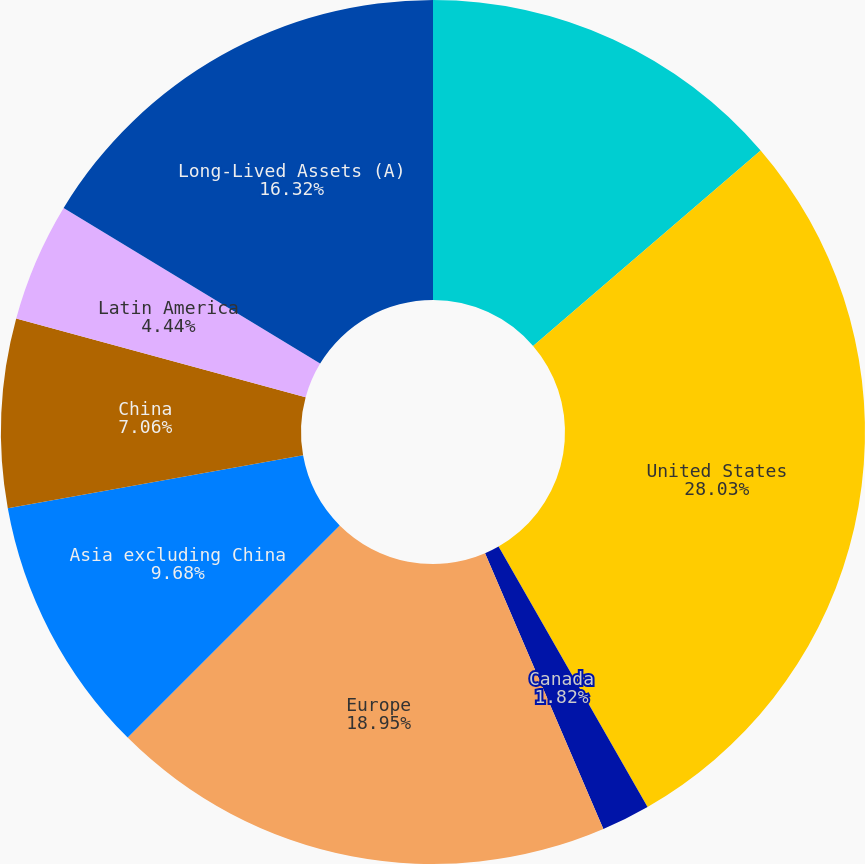<chart> <loc_0><loc_0><loc_500><loc_500><pie_chart><fcel>Sales to External Customers<fcel>United States<fcel>Canada<fcel>Europe<fcel>Asia excluding China<fcel>China<fcel>Latin America<fcel>Long-Lived Assets (A)<nl><fcel>13.7%<fcel>28.02%<fcel>1.82%<fcel>18.94%<fcel>9.68%<fcel>7.06%<fcel>4.44%<fcel>16.32%<nl></chart> 